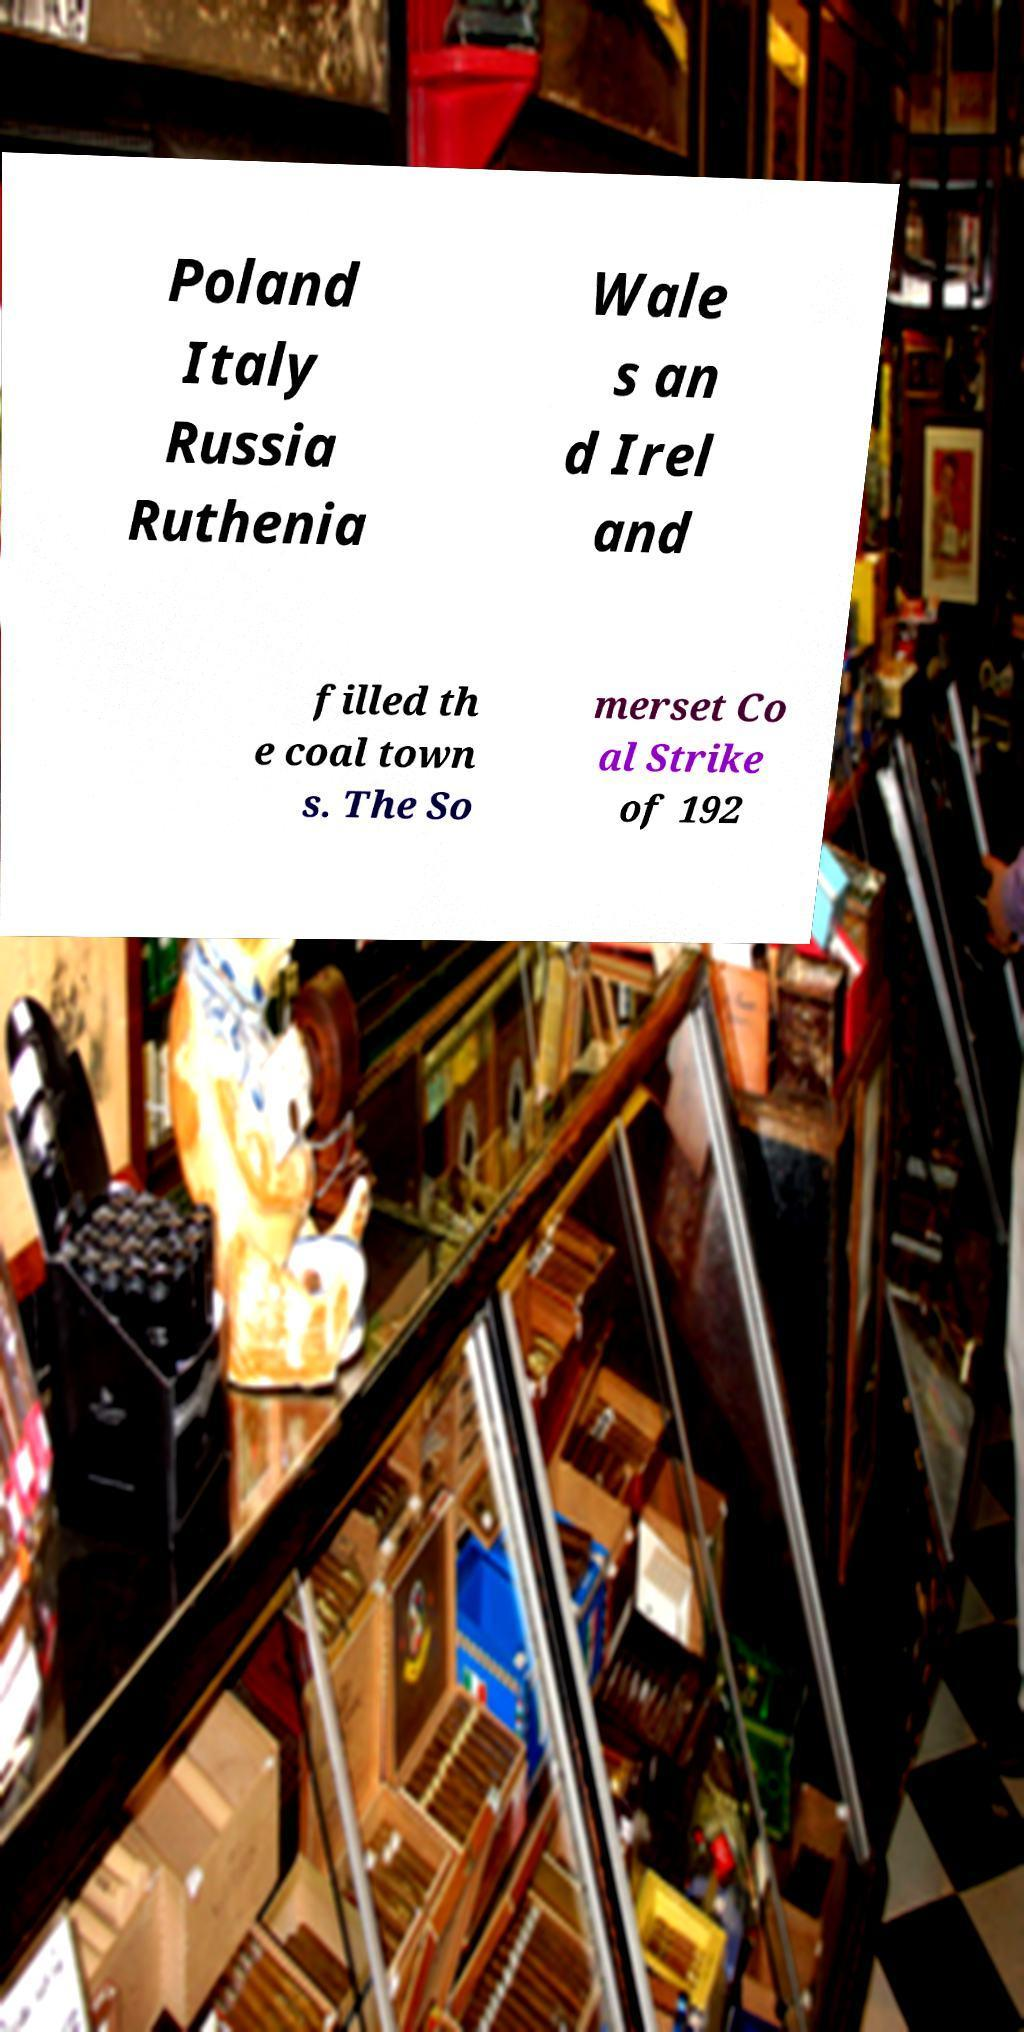There's text embedded in this image that I need extracted. Can you transcribe it verbatim? Poland Italy Russia Ruthenia Wale s an d Irel and filled th e coal town s. The So merset Co al Strike of 192 